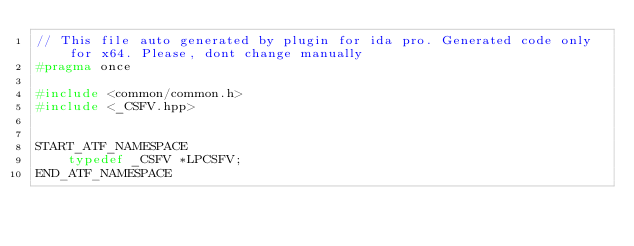<code> <loc_0><loc_0><loc_500><loc_500><_C++_>// This file auto generated by plugin for ida pro. Generated code only for x64. Please, dont change manually
#pragma once

#include <common/common.h>
#include <_CSFV.hpp>


START_ATF_NAMESPACE
    typedef _CSFV *LPCSFV;
END_ATF_NAMESPACE
</code> 